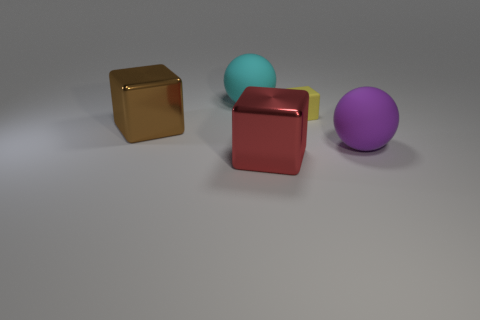Are there more tiny yellow cubes left of the brown metal block than yellow objects that are behind the big purple thing?
Offer a terse response. No. What number of other things are there of the same size as the brown metallic cube?
Keep it short and to the point. 3. Do the ball to the right of the small rubber thing and the red object have the same material?
Keep it short and to the point. No. How many other objects are the same shape as the brown object?
Provide a succinct answer. 2. Is the shape of the big purple rubber object that is right of the cyan rubber sphere the same as the big cyan matte object that is on the left side of the yellow matte thing?
Provide a short and direct response. Yes. Are there the same number of tiny cubes in front of the big brown object and big red shiny cubes that are to the right of the small yellow rubber thing?
Offer a terse response. Yes. What shape is the big shiny thing that is to the left of the ball that is behind the large metal object behind the red block?
Provide a short and direct response. Cube. Is the big purple ball behind the big red shiny block made of the same material as the tiny yellow cube that is in front of the large cyan ball?
Your response must be concise. Yes. What is the shape of the big matte object that is to the right of the red shiny object?
Your answer should be very brief. Sphere. Is the number of cubes less than the number of large things?
Offer a terse response. Yes. 